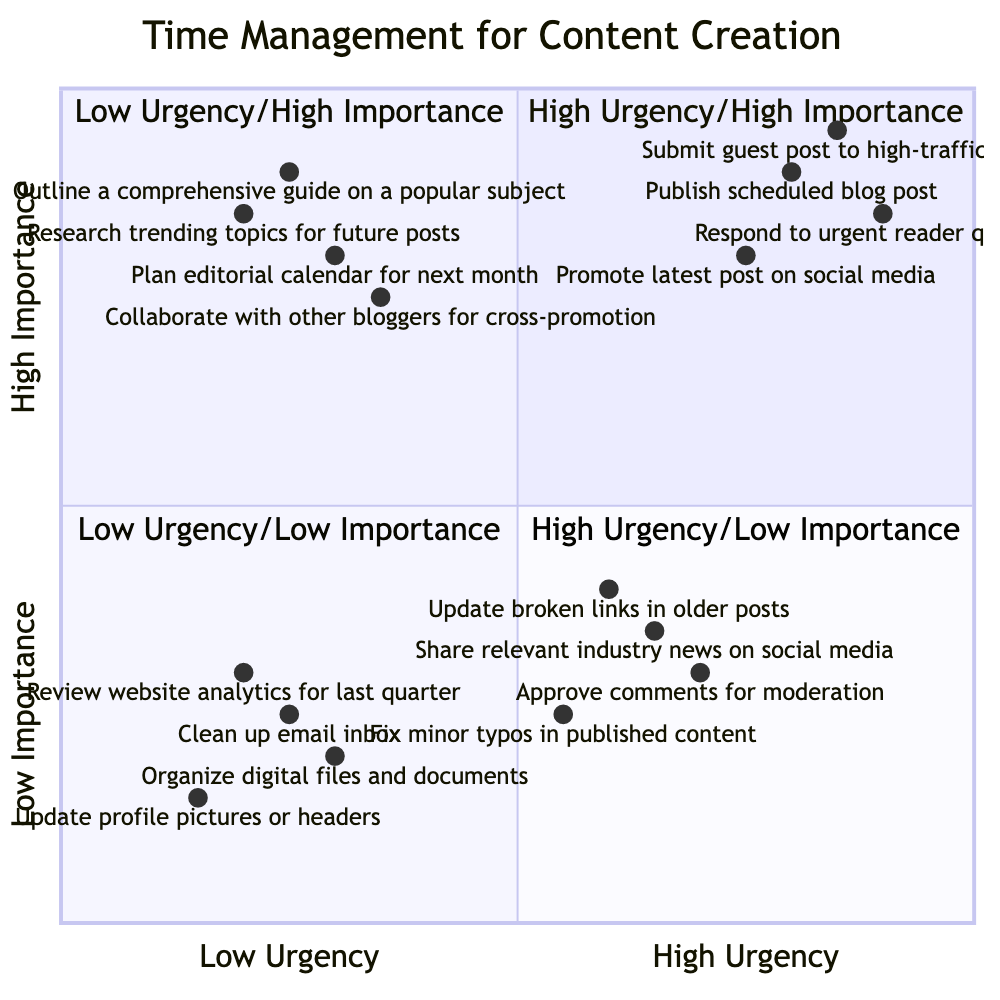What are the tasks listed in the High Urgency/Importance quadrant? The High Urgency/Importance quadrant contains four tasks: Publish scheduled blog post, Respond to urgent reader questions, Promote latest post on social media, and Submit guest post to high-traffic site.
Answer: Publish scheduled blog post, Respond to urgent reader questions, Promote latest post on social media, Submit guest post to high-traffic site Which task has the highest urgency and importance? In the High Urgency/Importance quadrant, the task "Submit guest post to high-traffic site" is positioned highest based on its urgency and importance values compared to the other tasks.
Answer: Submit guest post to high-traffic site How many tasks are in the Low Urgency/Low Importance quadrant? The Low Urgency/Low Importance quadrant contains four tasks: Review website analytics for last quarter, Organize digital files and documents, Clean up email inbox, and Update profile pictures or headers, making a total of four tasks.
Answer: Four tasks Which quadrant contains tasks related to future planning? The Low Urgency/High Importance quadrant contains tasks that focus on future planning, including Plan editorial calendar for next month, Research trending topics for future posts, and Outline a comprehensive guide on a popular subject.
Answer: Low Urgency/High Importance Are there any tasks in the High Urgency/Low Importance quadrant that focus on maintaining published content? Yes, the tasks "Update broken links in older posts" and "Fix minor typos in published content" in the High Urgency/Low Importance quadrant focus on maintaining existing published work.
Answer: Yes How does the urgency of "Promote latest post on social media" compare to "Share relevant industry news on social media"? "Promote latest post on social media" has a higher urgency level (0.75) compared to "Share relevant industry news on social media" (0.65), indicating it is a more urgent task.
Answer: Higher What is the combined total of tasks in both the High Urgency/Importance and Low Urgency/Importance quadrants? The total number of tasks in High Urgency/Importance is four and in Low Urgency/Importance is four, adding up to a total of eight tasks across both quadrants.
Answer: Eight tasks 